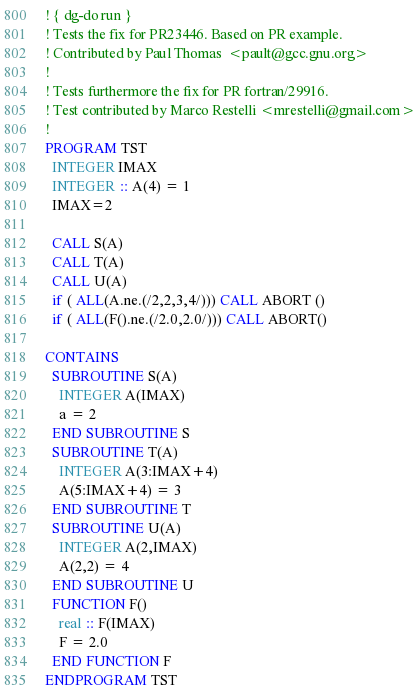Convert code to text. <code><loc_0><loc_0><loc_500><loc_500><_FORTRAN_>! { dg-do run }
! Tests the fix for PR23446. Based on PR example.
! Contributed by Paul Thomas  <pault@gcc.gnu.org>
!
! Tests furthermore the fix for PR fortran/29916.
! Test contributed by Marco Restelli <mrestelli@gmail.com>
!
PROGRAM TST
  INTEGER IMAX
  INTEGER :: A(4) = 1
  IMAX=2

  CALL S(A)
  CALL T(A)
  CALL U(A)
  if ( ALL(A.ne.(/2,2,3,4/))) CALL ABORT ()
  if ( ALL(F().ne.(/2.0,2.0/))) CALL ABORT()

CONTAINS
  SUBROUTINE S(A)
    INTEGER A(IMAX)
    a = 2
  END SUBROUTINE S
  SUBROUTINE T(A)
    INTEGER A(3:IMAX+4)
    A(5:IMAX+4) = 3
  END SUBROUTINE T
  SUBROUTINE U(A)
    INTEGER A(2,IMAX)
    A(2,2) = 4
  END SUBROUTINE U
  FUNCTION F()
    real :: F(IMAX)
    F = 2.0
  END FUNCTION F
ENDPROGRAM TST
</code> 